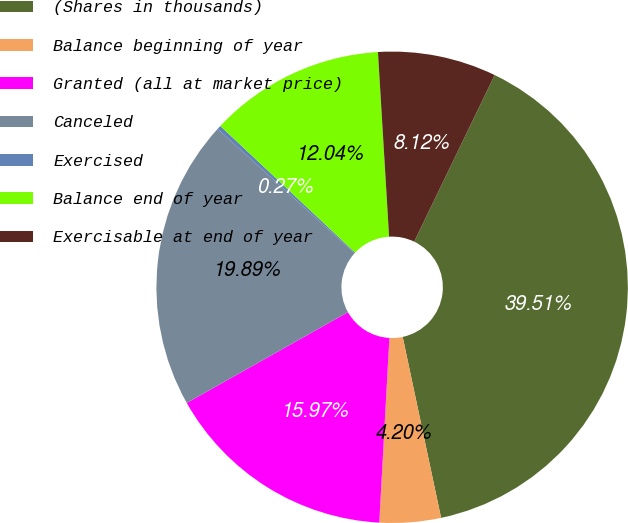Convert chart. <chart><loc_0><loc_0><loc_500><loc_500><pie_chart><fcel>(Shares in thousands)<fcel>Balance beginning of year<fcel>Granted (all at market price)<fcel>Canceled<fcel>Exercised<fcel>Balance end of year<fcel>Exercisable at end of year<nl><fcel>39.51%<fcel>4.2%<fcel>15.97%<fcel>19.89%<fcel>0.27%<fcel>12.04%<fcel>8.12%<nl></chart> 